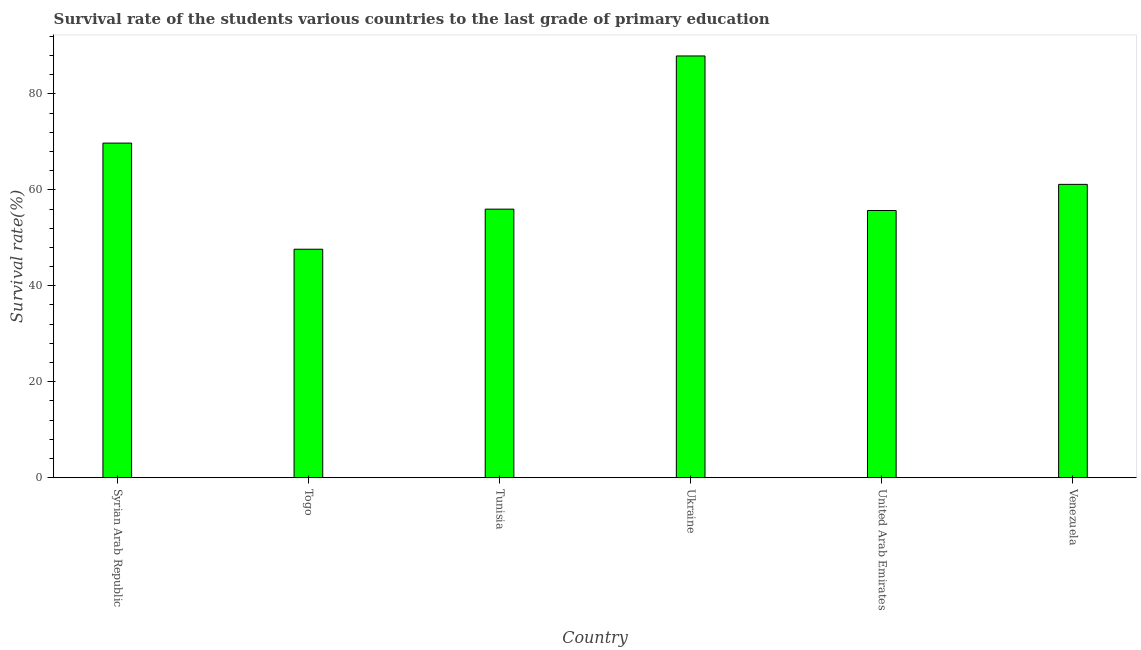What is the title of the graph?
Your answer should be very brief. Survival rate of the students various countries to the last grade of primary education. What is the label or title of the X-axis?
Your answer should be compact. Country. What is the label or title of the Y-axis?
Provide a succinct answer. Survival rate(%). What is the survival rate in primary education in Syrian Arab Republic?
Give a very brief answer. 69.76. Across all countries, what is the maximum survival rate in primary education?
Your response must be concise. 87.93. Across all countries, what is the minimum survival rate in primary education?
Keep it short and to the point. 47.63. In which country was the survival rate in primary education maximum?
Your answer should be very brief. Ukraine. In which country was the survival rate in primary education minimum?
Offer a terse response. Togo. What is the sum of the survival rate in primary education?
Give a very brief answer. 378.15. What is the difference between the survival rate in primary education in Syrian Arab Republic and Ukraine?
Your answer should be compact. -18.17. What is the average survival rate in primary education per country?
Provide a short and direct response. 63.02. What is the median survival rate in primary education?
Make the answer very short. 58.57. In how many countries, is the survival rate in primary education greater than 8 %?
Your response must be concise. 6. What is the ratio of the survival rate in primary education in Tunisia to that in Venezuela?
Your answer should be very brief. 0.92. Is the survival rate in primary education in Togo less than that in Tunisia?
Keep it short and to the point. Yes. What is the difference between the highest and the second highest survival rate in primary education?
Provide a short and direct response. 18.17. What is the difference between the highest and the lowest survival rate in primary education?
Provide a short and direct response. 40.3. How many bars are there?
Your answer should be very brief. 6. How many countries are there in the graph?
Provide a succinct answer. 6. What is the difference between two consecutive major ticks on the Y-axis?
Offer a very short reply. 20. What is the Survival rate(%) in Syrian Arab Republic?
Your response must be concise. 69.76. What is the Survival rate(%) in Togo?
Offer a very short reply. 47.63. What is the Survival rate(%) of Tunisia?
Offer a terse response. 55.98. What is the Survival rate(%) of Ukraine?
Give a very brief answer. 87.93. What is the Survival rate(%) in United Arab Emirates?
Offer a very short reply. 55.71. What is the Survival rate(%) in Venezuela?
Offer a terse response. 61.15. What is the difference between the Survival rate(%) in Syrian Arab Republic and Togo?
Give a very brief answer. 22.13. What is the difference between the Survival rate(%) in Syrian Arab Republic and Tunisia?
Provide a succinct answer. 13.77. What is the difference between the Survival rate(%) in Syrian Arab Republic and Ukraine?
Your answer should be very brief. -18.17. What is the difference between the Survival rate(%) in Syrian Arab Republic and United Arab Emirates?
Your answer should be compact. 14.05. What is the difference between the Survival rate(%) in Syrian Arab Republic and Venezuela?
Offer a very short reply. 8.6. What is the difference between the Survival rate(%) in Togo and Tunisia?
Offer a very short reply. -8.36. What is the difference between the Survival rate(%) in Togo and Ukraine?
Offer a terse response. -40.3. What is the difference between the Survival rate(%) in Togo and United Arab Emirates?
Give a very brief answer. -8.08. What is the difference between the Survival rate(%) in Togo and Venezuela?
Your response must be concise. -13.53. What is the difference between the Survival rate(%) in Tunisia and Ukraine?
Provide a short and direct response. -31.94. What is the difference between the Survival rate(%) in Tunisia and United Arab Emirates?
Your answer should be compact. 0.28. What is the difference between the Survival rate(%) in Tunisia and Venezuela?
Offer a very short reply. -5.17. What is the difference between the Survival rate(%) in Ukraine and United Arab Emirates?
Your answer should be very brief. 32.22. What is the difference between the Survival rate(%) in Ukraine and Venezuela?
Offer a terse response. 26.77. What is the difference between the Survival rate(%) in United Arab Emirates and Venezuela?
Offer a very short reply. -5.45. What is the ratio of the Survival rate(%) in Syrian Arab Republic to that in Togo?
Your answer should be very brief. 1.47. What is the ratio of the Survival rate(%) in Syrian Arab Republic to that in Tunisia?
Your answer should be compact. 1.25. What is the ratio of the Survival rate(%) in Syrian Arab Republic to that in Ukraine?
Offer a terse response. 0.79. What is the ratio of the Survival rate(%) in Syrian Arab Republic to that in United Arab Emirates?
Keep it short and to the point. 1.25. What is the ratio of the Survival rate(%) in Syrian Arab Republic to that in Venezuela?
Ensure brevity in your answer.  1.14. What is the ratio of the Survival rate(%) in Togo to that in Tunisia?
Keep it short and to the point. 0.85. What is the ratio of the Survival rate(%) in Togo to that in Ukraine?
Give a very brief answer. 0.54. What is the ratio of the Survival rate(%) in Togo to that in United Arab Emirates?
Offer a terse response. 0.85. What is the ratio of the Survival rate(%) in Togo to that in Venezuela?
Your answer should be very brief. 0.78. What is the ratio of the Survival rate(%) in Tunisia to that in Ukraine?
Offer a terse response. 0.64. What is the ratio of the Survival rate(%) in Tunisia to that in Venezuela?
Provide a short and direct response. 0.92. What is the ratio of the Survival rate(%) in Ukraine to that in United Arab Emirates?
Make the answer very short. 1.58. What is the ratio of the Survival rate(%) in Ukraine to that in Venezuela?
Offer a terse response. 1.44. What is the ratio of the Survival rate(%) in United Arab Emirates to that in Venezuela?
Ensure brevity in your answer.  0.91. 